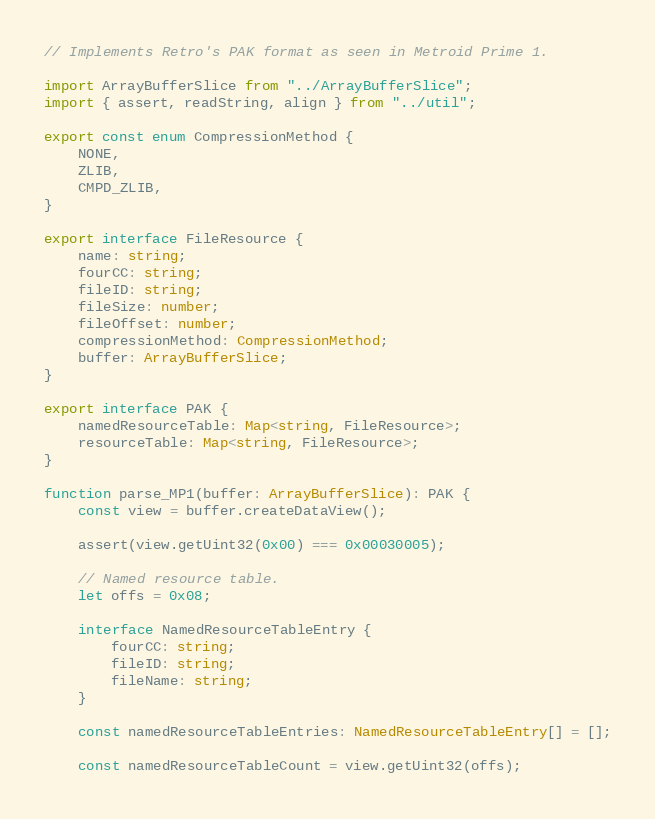Convert code to text. <code><loc_0><loc_0><loc_500><loc_500><_TypeScript_>
// Implements Retro's PAK format as seen in Metroid Prime 1.

import ArrayBufferSlice from "../ArrayBufferSlice";
import { assert, readString, align } from "../util";

export const enum CompressionMethod {
    NONE,
    ZLIB,
    CMPD_ZLIB,
}

export interface FileResource {
    name: string;
    fourCC: string;
    fileID: string;
    fileSize: number;
    fileOffset: number;
    compressionMethod: CompressionMethod;
    buffer: ArrayBufferSlice;
}

export interface PAK {
    namedResourceTable: Map<string, FileResource>;
    resourceTable: Map<string, FileResource>;
}

function parse_MP1(buffer: ArrayBufferSlice): PAK {
    const view = buffer.createDataView();

    assert(view.getUint32(0x00) === 0x00030005);

    // Named resource table.
    let offs = 0x08;

    interface NamedResourceTableEntry {
        fourCC: string;
        fileID: string;
        fileName: string;
    }

    const namedResourceTableEntries: NamedResourceTableEntry[] = [];

    const namedResourceTableCount = view.getUint32(offs);</code> 